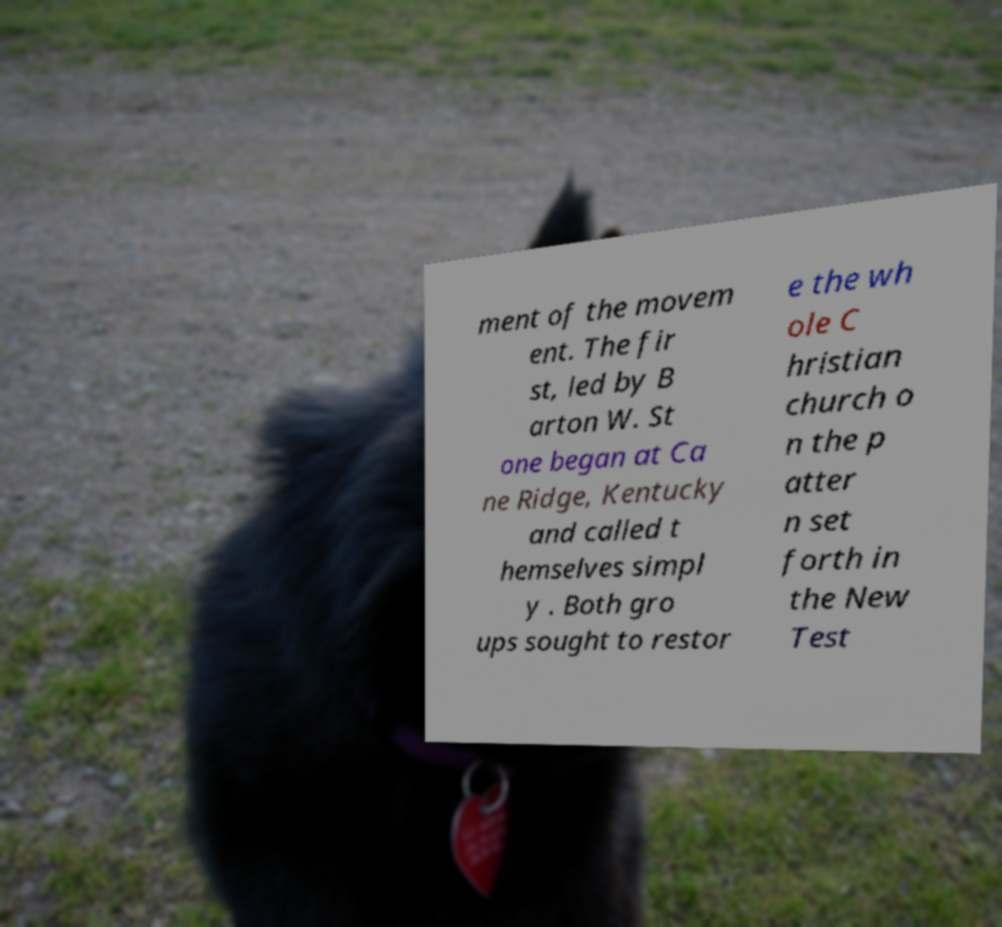Please read and relay the text visible in this image. What does it say? ment of the movem ent. The fir st, led by B arton W. St one began at Ca ne Ridge, Kentucky and called t hemselves simpl y . Both gro ups sought to restor e the wh ole C hristian church o n the p atter n set forth in the New Test 